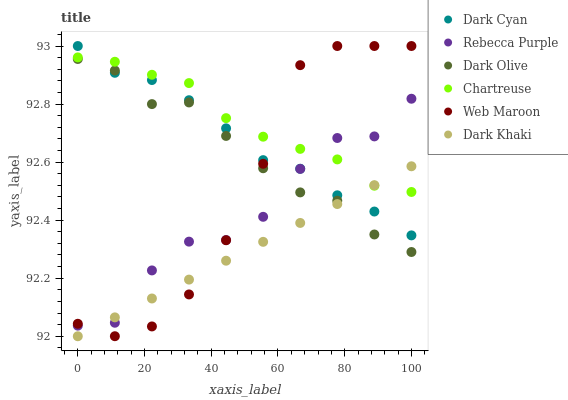Does Dark Khaki have the minimum area under the curve?
Answer yes or no. Yes. Does Chartreuse have the maximum area under the curve?
Answer yes or no. Yes. Does Web Maroon have the minimum area under the curve?
Answer yes or no. No. Does Web Maroon have the maximum area under the curve?
Answer yes or no. No. Is Dark Khaki the smoothest?
Answer yes or no. Yes. Is Rebecca Purple the roughest?
Answer yes or no. Yes. Is Web Maroon the smoothest?
Answer yes or no. No. Is Web Maroon the roughest?
Answer yes or no. No. Does Dark Khaki have the lowest value?
Answer yes or no. Yes. Does Web Maroon have the lowest value?
Answer yes or no. No. Does Dark Cyan have the highest value?
Answer yes or no. Yes. Does Dark Khaki have the highest value?
Answer yes or no. No. Is Dark Olive less than Chartreuse?
Answer yes or no. Yes. Is Chartreuse greater than Dark Olive?
Answer yes or no. Yes. Does Dark Cyan intersect Rebecca Purple?
Answer yes or no. Yes. Is Dark Cyan less than Rebecca Purple?
Answer yes or no. No. Is Dark Cyan greater than Rebecca Purple?
Answer yes or no. No. Does Dark Olive intersect Chartreuse?
Answer yes or no. No. 